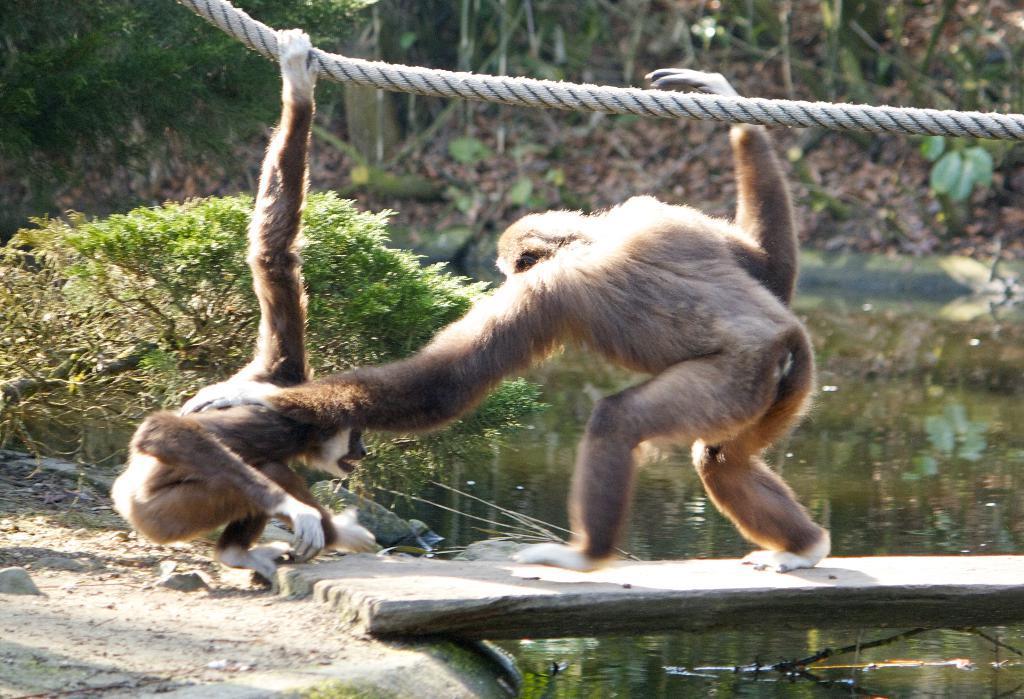How would you summarize this image in a sentence or two? In this picture there is an animal standing on the wooden object and there is an animal holding the rope. At the top there is a rope. At the back there are trees and plants. At the bottom there is water and there is ground. 